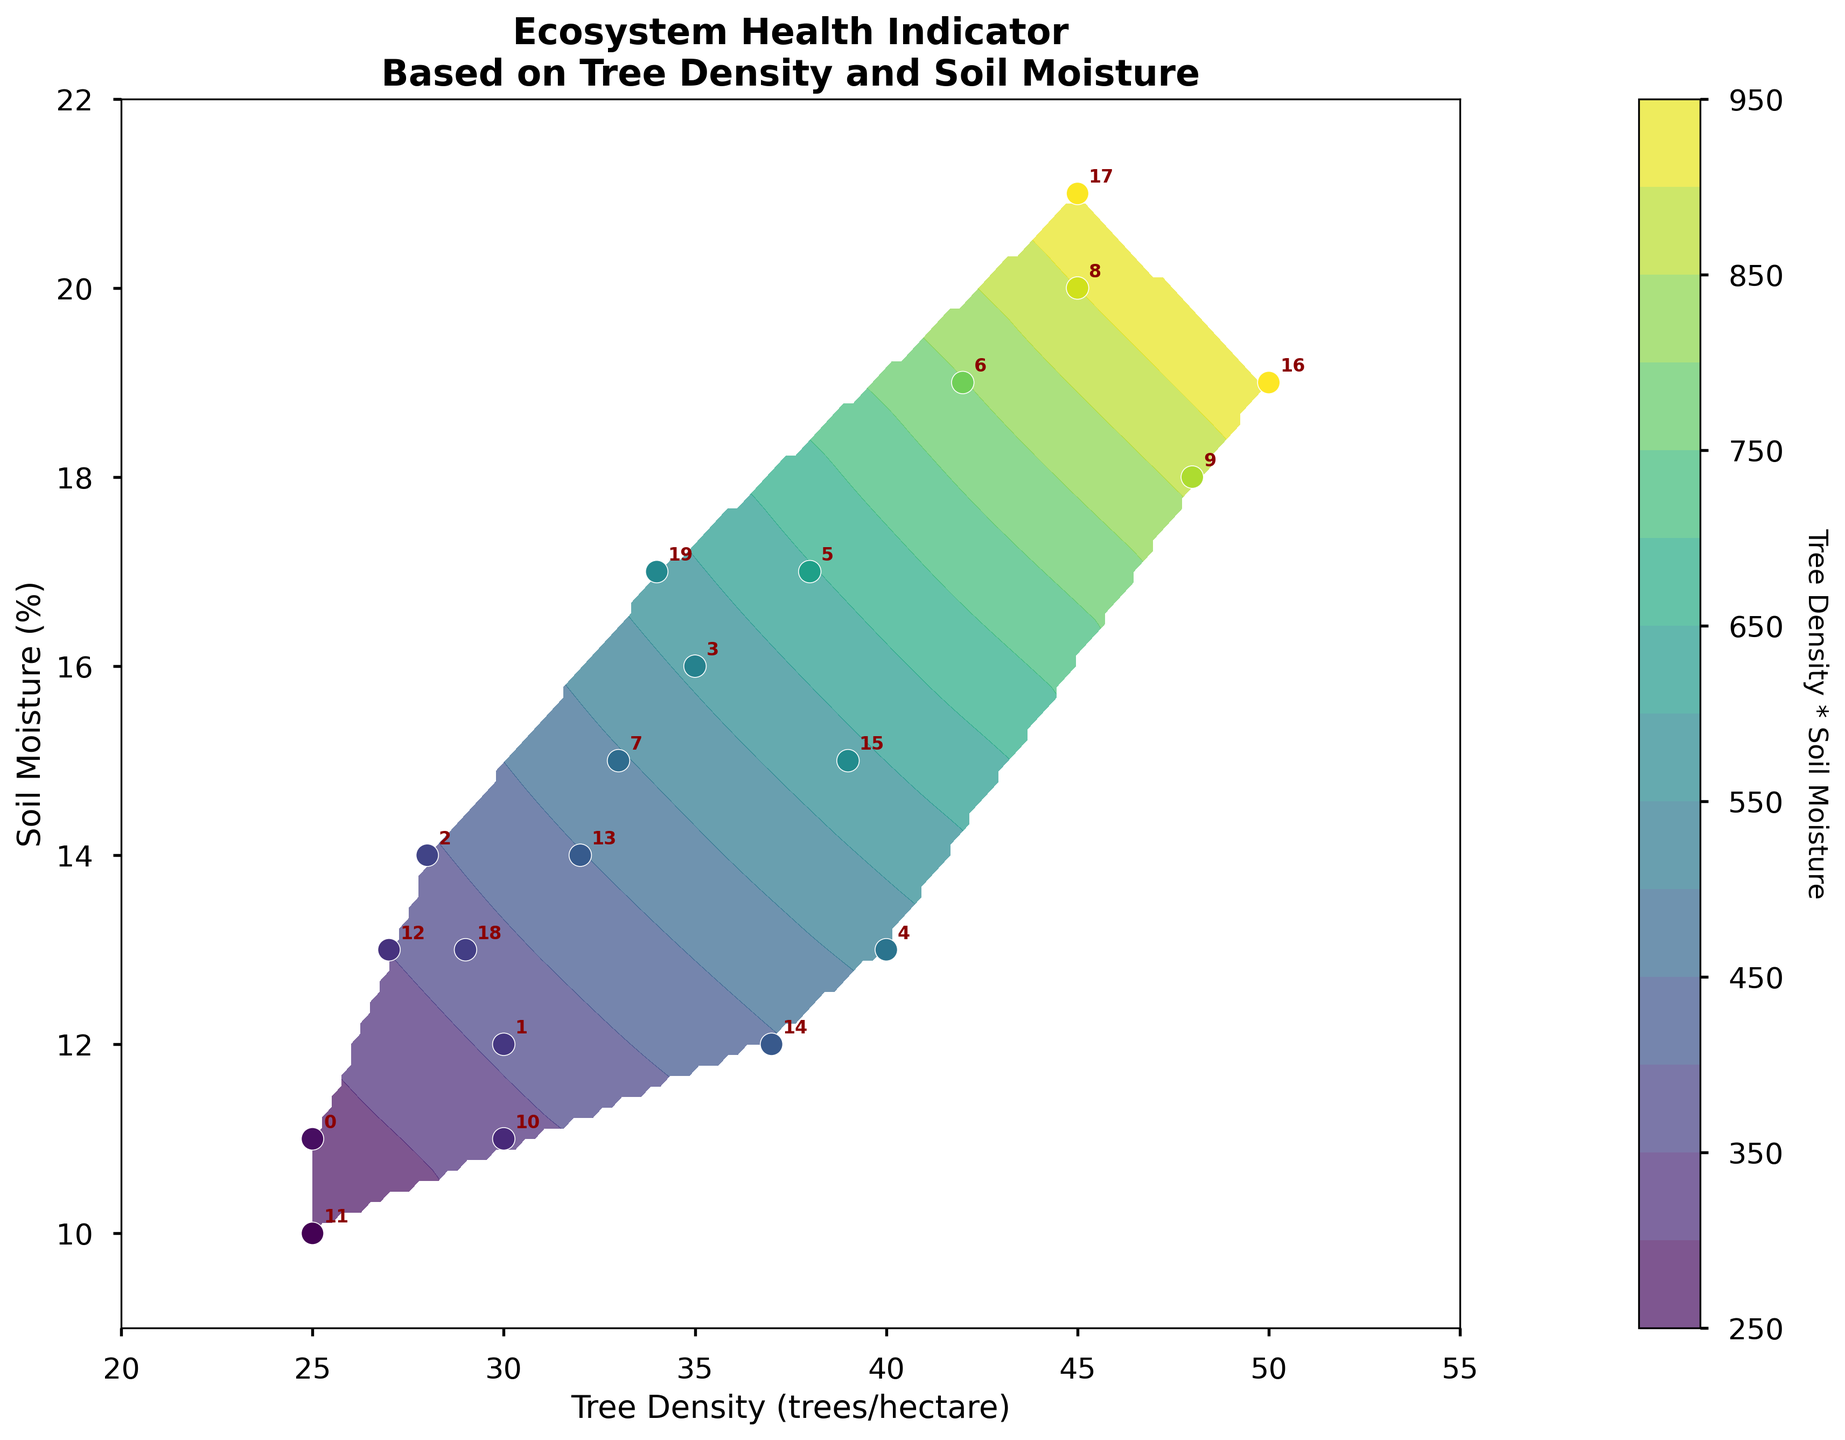What is the title of the plot? The title is usually placed at the top of the plot. In this case, the title "Ecosystem Health Indicator Based on Tree Density and Soil Moisture" is clearly visible.
Answer: Ecosystem Health Indicator Based on Tree Density and Soil Moisture What are the labels for the x and y axes? Axis labels describe what each axis represents. Here, the x-axis is labeled "Tree Density (trees/hectare)" and the y-axis is labeled "Soil Moisture (%)".
Answer: Tree Density (trees/hectare) and Soil Moisture (%) How many data points are plotted on the scatter plot? To find the number of data points, count all labeled points on the scatter plot. There are 20 data points as indicated by the labels corresponding to each index.
Answer: 20 At what Tree Density and Soil Moisture is the highest value of the contour plot observed? The highest values of the contour plot can be identified by the darkest color in the color scale. Observing the color scale and the contour areas, the highest value appears in the region where Tree Density is around 50 and Soil Moisture is around 19-21.
Answer: Around 50 Tree Density and 19-21 Soil Moisture What color represents the lowest values in the plot? The color scale bar to the right of the plot indicates that lighter colors represent lower values. The lowest values are shown in light yellow.
Answer: Light yellow Which data point has the highest Tree Density and what is its Soil Moisture percentage? Locate the data point with the highest x-value on the plot. The highest Tree Density is 50, matched with a Soil Moisture percentage of 19 (row index 16).
Answer: 50 Tree Density and 19 Soil Moisture How does Tree Density affect Soil Moisture in the plot? Observing the plot, higher Tree Density appears to generally correlate with higher Soil Moisture. This suggests a positive relationship where plots with more trees also have higher soil moisture.
Answer: Positive correlation What trend can be observed in the contour levels across the plot? The contour levels indicate the product of Tree Density and Soil Moisture. The trend shows that higher contour levels (darker colors) are found where both Tree Density and Soil Moisture are higher, indicating an increasing product value.
Answer: Higher product value in areas with higher Tree Density and Soil Moisture Are there any outliers in terms of Tree Density or Soil Moisture? To identify outliers, check for any points significantly distant from others in the plot. In this case, no data points show extreme separation from the clusters.
Answer: No visible outliers What is the combined Tree Density and Soil Moisture for the point at index 9? Locate index 9 on the plot, which corresponds to 48 Tree Density and 18 Soil Moisture. The combined value (product) is 48 * 18.
Answer: 864 